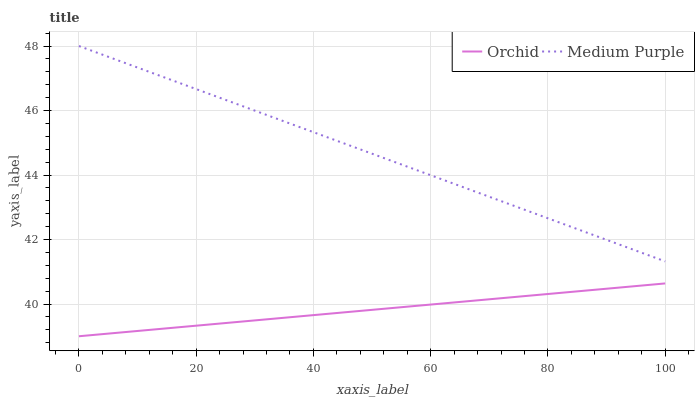Does Orchid have the minimum area under the curve?
Answer yes or no. Yes. Does Medium Purple have the maximum area under the curve?
Answer yes or no. Yes. Does Orchid have the maximum area under the curve?
Answer yes or no. No. Is Medium Purple the smoothest?
Answer yes or no. Yes. Is Orchid the roughest?
Answer yes or no. Yes. Is Orchid the smoothest?
Answer yes or no. No. Does Orchid have the lowest value?
Answer yes or no. Yes. Does Medium Purple have the highest value?
Answer yes or no. Yes. Does Orchid have the highest value?
Answer yes or no. No. Is Orchid less than Medium Purple?
Answer yes or no. Yes. Is Medium Purple greater than Orchid?
Answer yes or no. Yes. Does Orchid intersect Medium Purple?
Answer yes or no. No. 